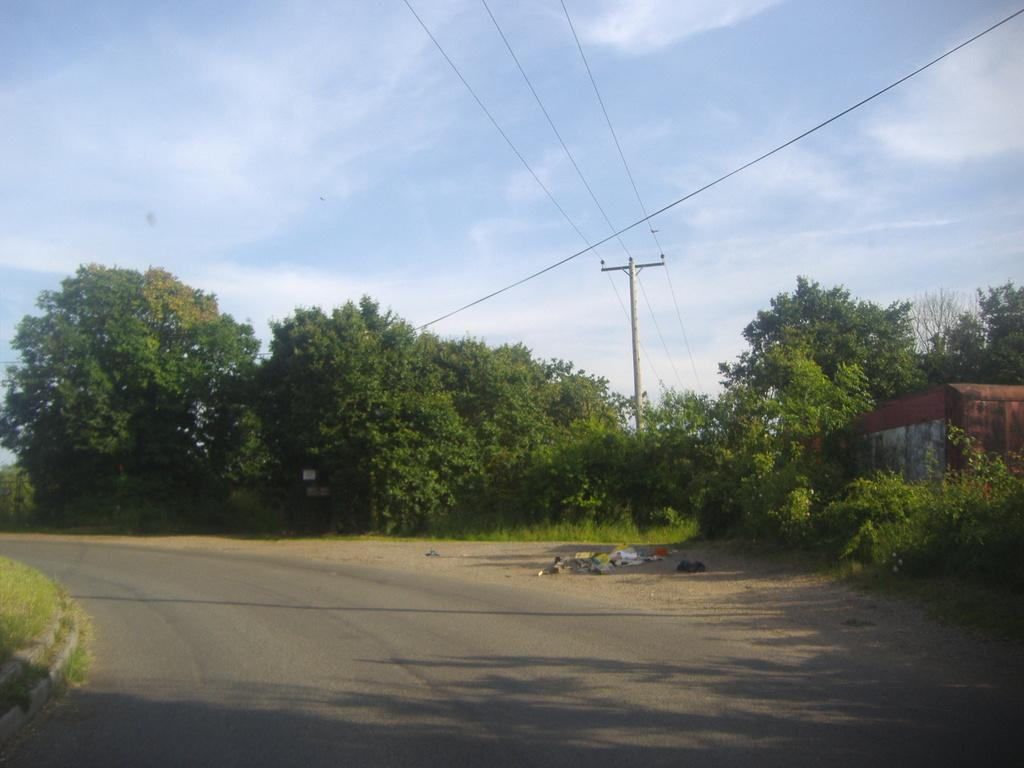What is the setting of the image? The image shows an outside view of the city. What can be seen in the sky in the image? The sky is visible in the image. What type of infrastructure is present in the image? Power line cables and a pole are visible in the image. What type of natural elements are present in the image? Trees are present in the image. What type of copper design can be seen on the boys' clothing in the image? There are no boys or copper designs present in the image. 